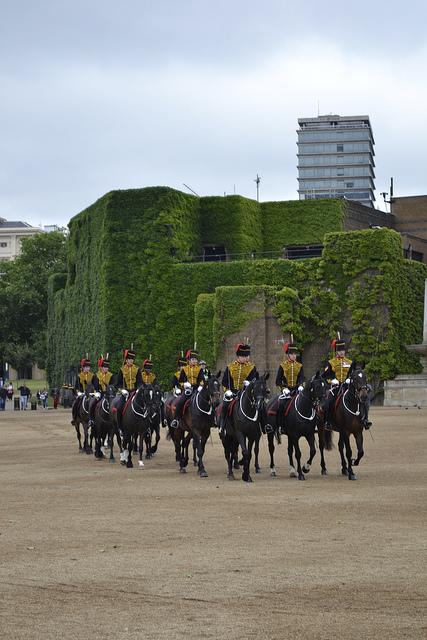Is this considered a cavalry?
Give a very brief answer. Yes. What are the people riding?
Quick response, please. Horses. Could you trim the hedge without a ladder?
Keep it brief. No. How many horses are there?
Be succinct. 8. What color are the helmets?
Concise answer only. Black. 